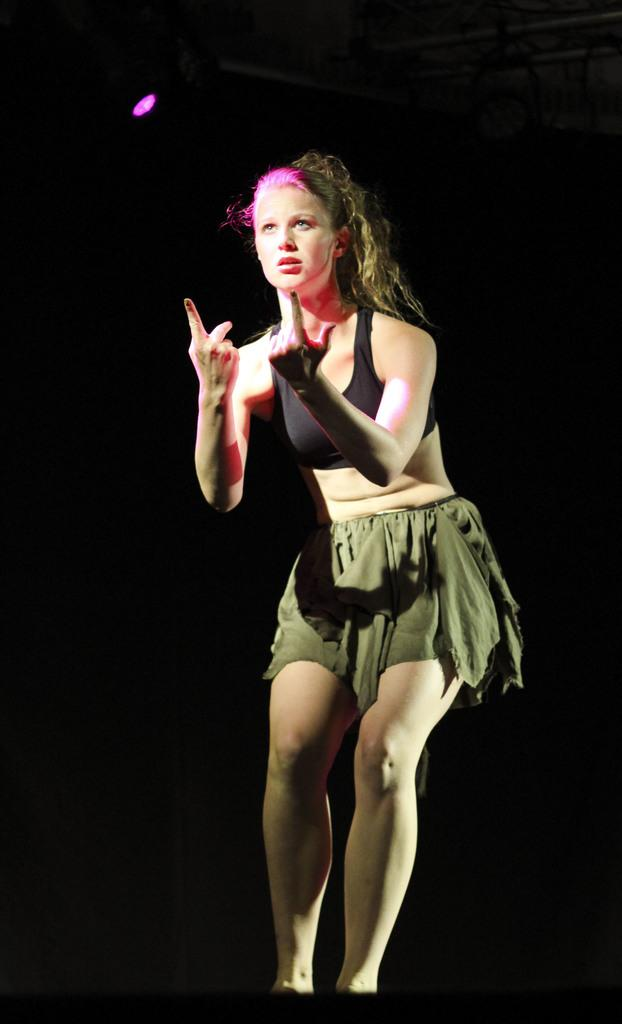What is the main subject of the image? The main subject of the image is a woman standing. What is the woman wearing in the image? The woman is wearing clothes in the image. What color is the light in the image? The light in the image is pink in color. How would you describe the background of the image? The background of the image is dark. How does the stranger in the image feel about the ongoing battle? There is no stranger or battle present in the image; it features a woman standing in a pink-lit environment with a dark background. 